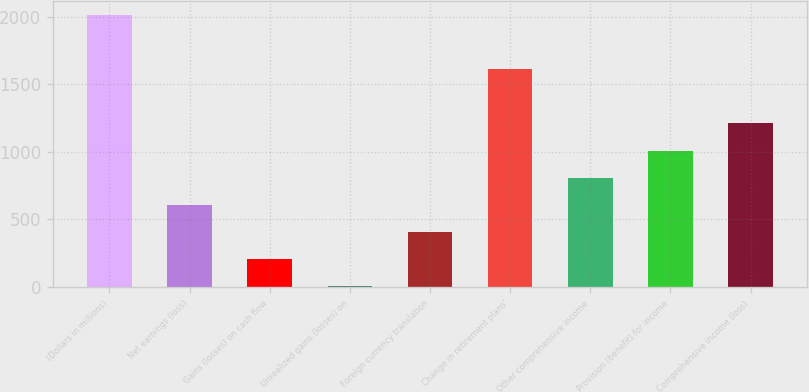Convert chart to OTSL. <chart><loc_0><loc_0><loc_500><loc_500><bar_chart><fcel>(Dollars in millions)<fcel>Net earnings (loss)<fcel>Gains (losses) on cash flow<fcel>Unrealized gains (losses) on<fcel>Foreign currency translation<fcel>Change in retirement plans'<fcel>Other comprehensive income<fcel>Provision (benefit) for income<fcel>Comprehensive income (loss)<nl><fcel>2012<fcel>607.8<fcel>206.6<fcel>6<fcel>407.2<fcel>1610.8<fcel>808.4<fcel>1009<fcel>1209.6<nl></chart> 